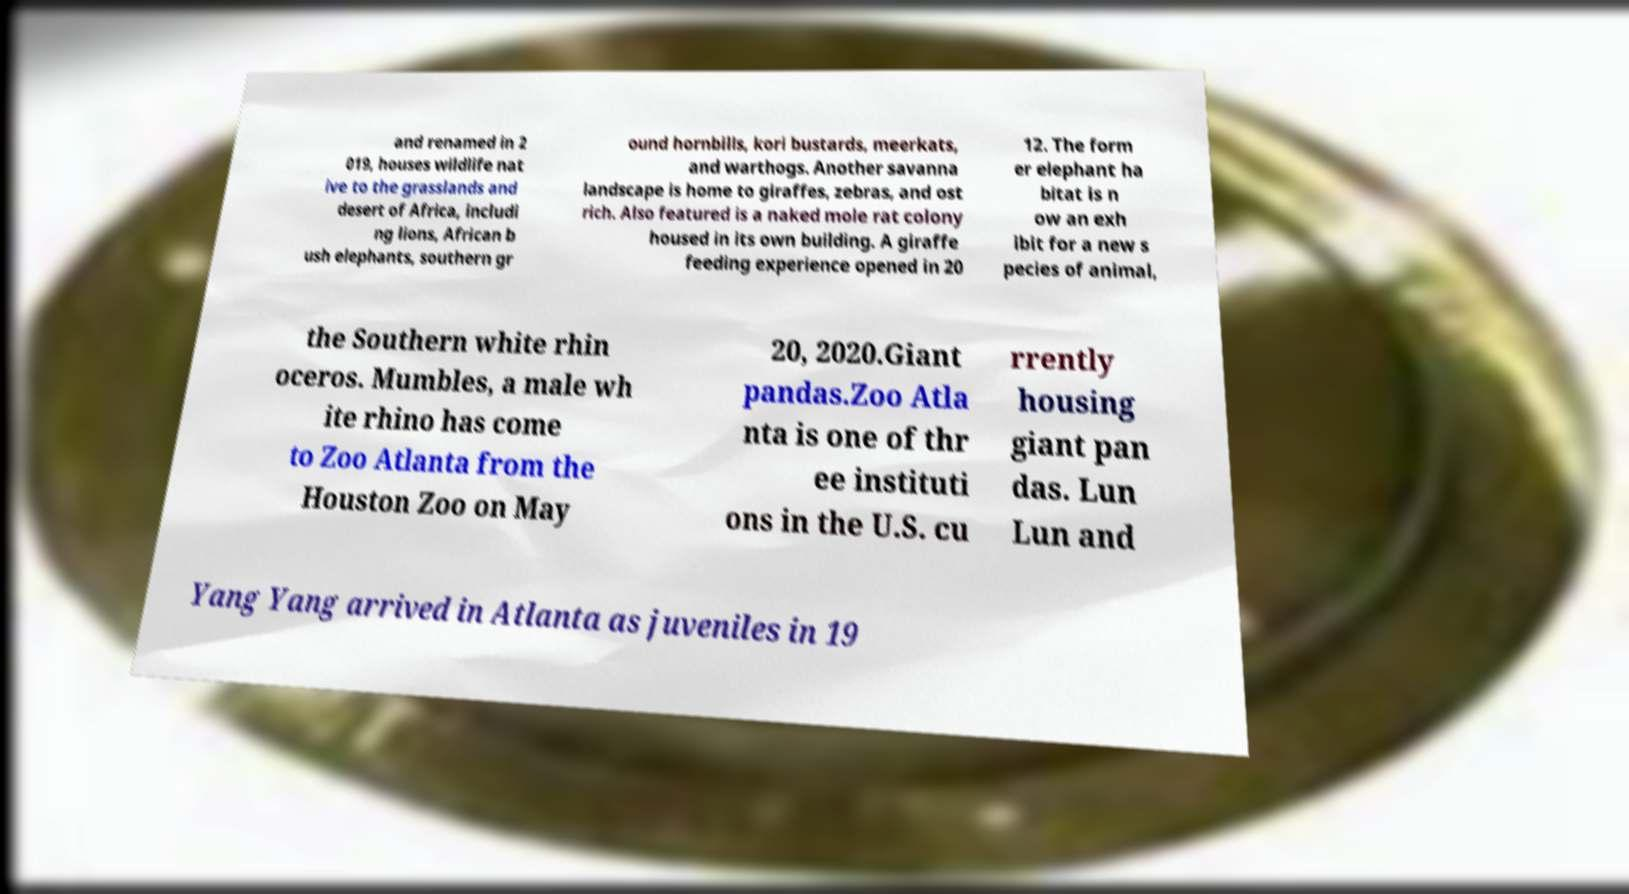Please identify and transcribe the text found in this image. and renamed in 2 019, houses wildlife nat ive to the grasslands and desert of Africa, includi ng lions, African b ush elephants, southern gr ound hornbills, kori bustards, meerkats, and warthogs. Another savanna landscape is home to giraffes, zebras, and ost rich. Also featured is a naked mole rat colony housed in its own building. A giraffe feeding experience opened in 20 12. The form er elephant ha bitat is n ow an exh ibit for a new s pecies of animal, the Southern white rhin oceros. Mumbles, a male wh ite rhino has come to Zoo Atlanta from the Houston Zoo on May 20, 2020.Giant pandas.Zoo Atla nta is one of thr ee instituti ons in the U.S. cu rrently housing giant pan das. Lun Lun and Yang Yang arrived in Atlanta as juveniles in 19 